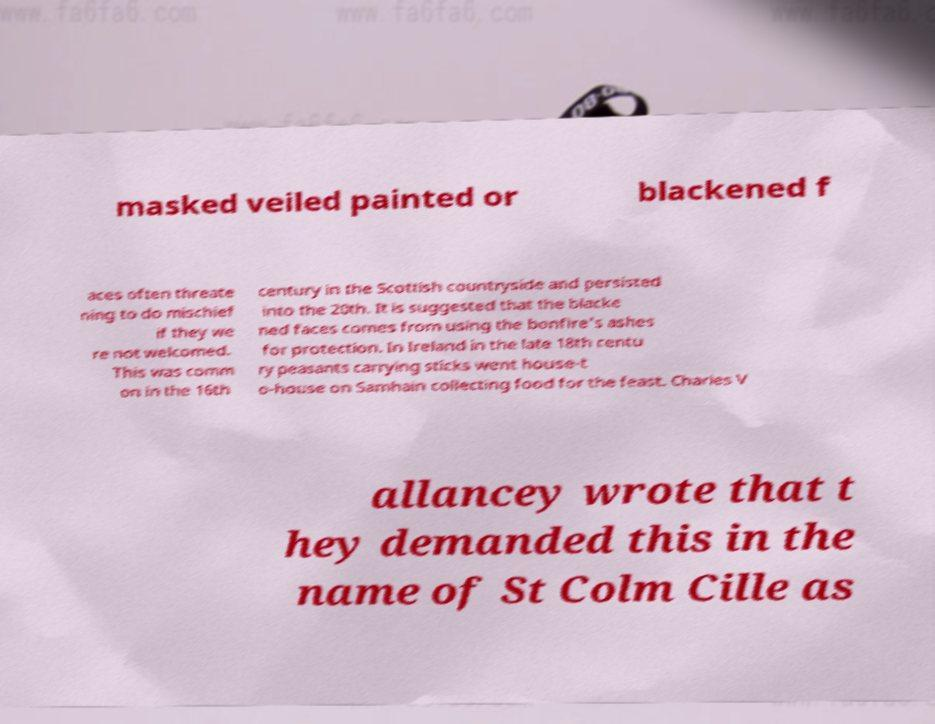Please read and relay the text visible in this image. What does it say? masked veiled painted or blackened f aces often threate ning to do mischief if they we re not welcomed. This was comm on in the 16th century in the Scottish countryside and persisted into the 20th. It is suggested that the blacke ned faces comes from using the bonfire's ashes for protection. In Ireland in the late 18th centu ry peasants carrying sticks went house-t o-house on Samhain collecting food for the feast. Charles V allancey wrote that t hey demanded this in the name of St Colm Cille as 